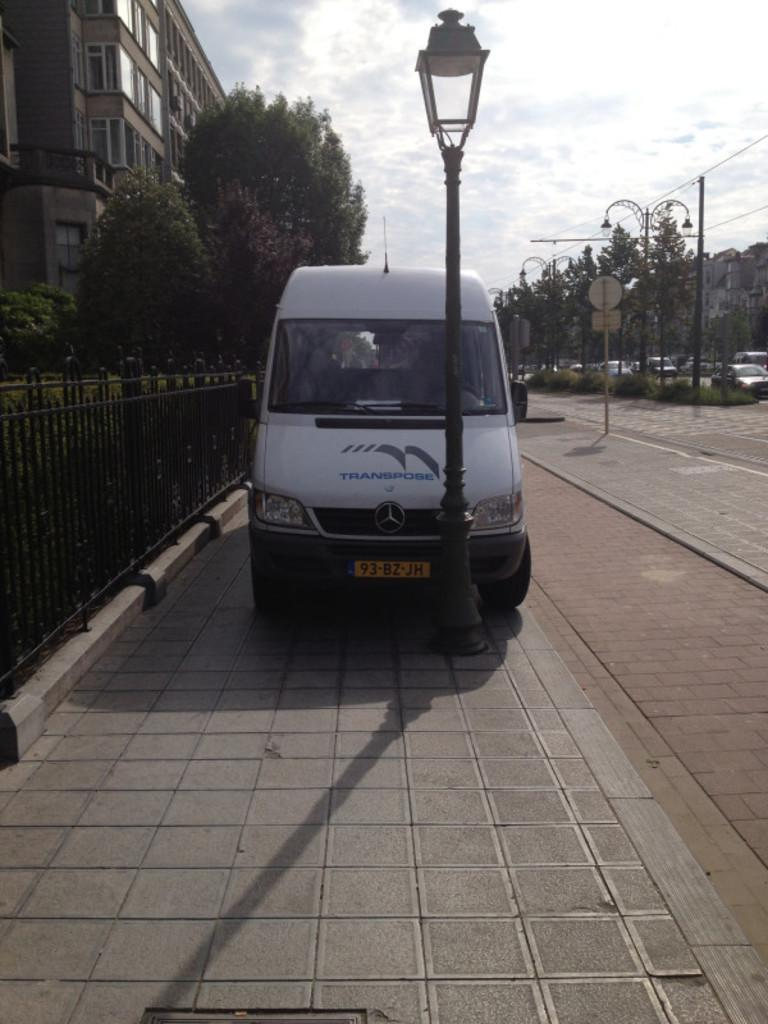Provide a one-sentence caption for the provided image. A van with the license plate 93-BZ-JH is parked on a sidewalk by a lamp post. 